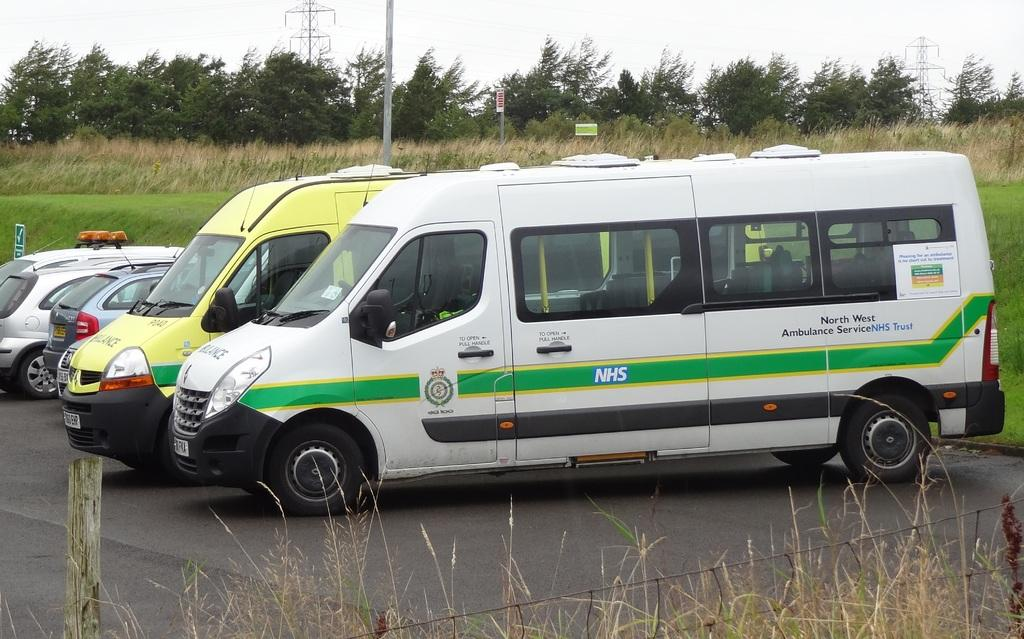<image>
Offer a succinct explanation of the picture presented. The transport van is from North West Ambulance Service. 